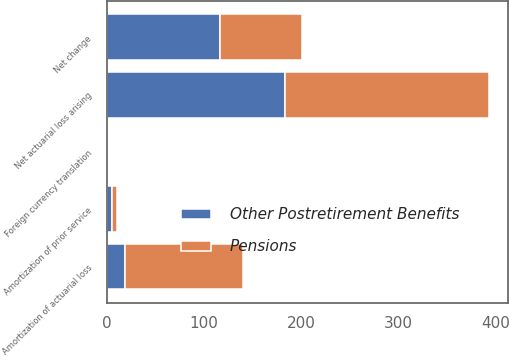Convert chart. <chart><loc_0><loc_0><loc_500><loc_500><stacked_bar_chart><ecel><fcel>Net actuarial loss arising<fcel>Amortization of actuarial loss<fcel>Amortization of prior service<fcel>Foreign currency translation<fcel>Net change<nl><fcel>Pensions<fcel>210<fcel>121<fcel>5<fcel>1<fcel>85<nl><fcel>Other Postretirement Benefits<fcel>183<fcel>19<fcel>5<fcel>1<fcel>116<nl></chart> 